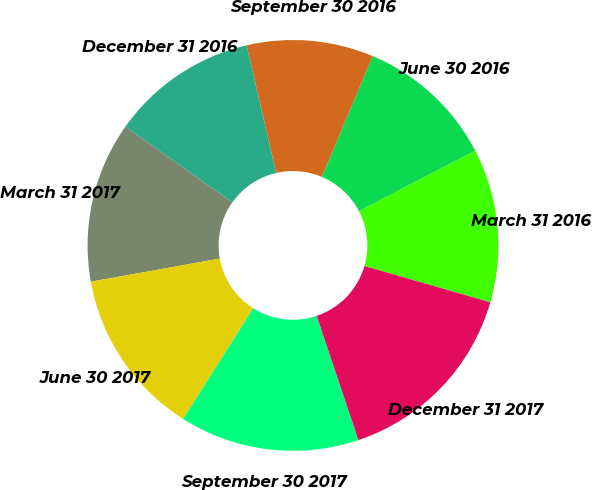<chart> <loc_0><loc_0><loc_500><loc_500><pie_chart><fcel>March 31 2016<fcel>June 30 2016<fcel>September 30 2016<fcel>December 31 2016<fcel>March 31 2017<fcel>June 30 2017<fcel>September 30 2017<fcel>December 31 2017<nl><fcel>12.1%<fcel>11.02%<fcel>9.97%<fcel>11.56%<fcel>12.64%<fcel>13.19%<fcel>14.14%<fcel>15.37%<nl></chart> 